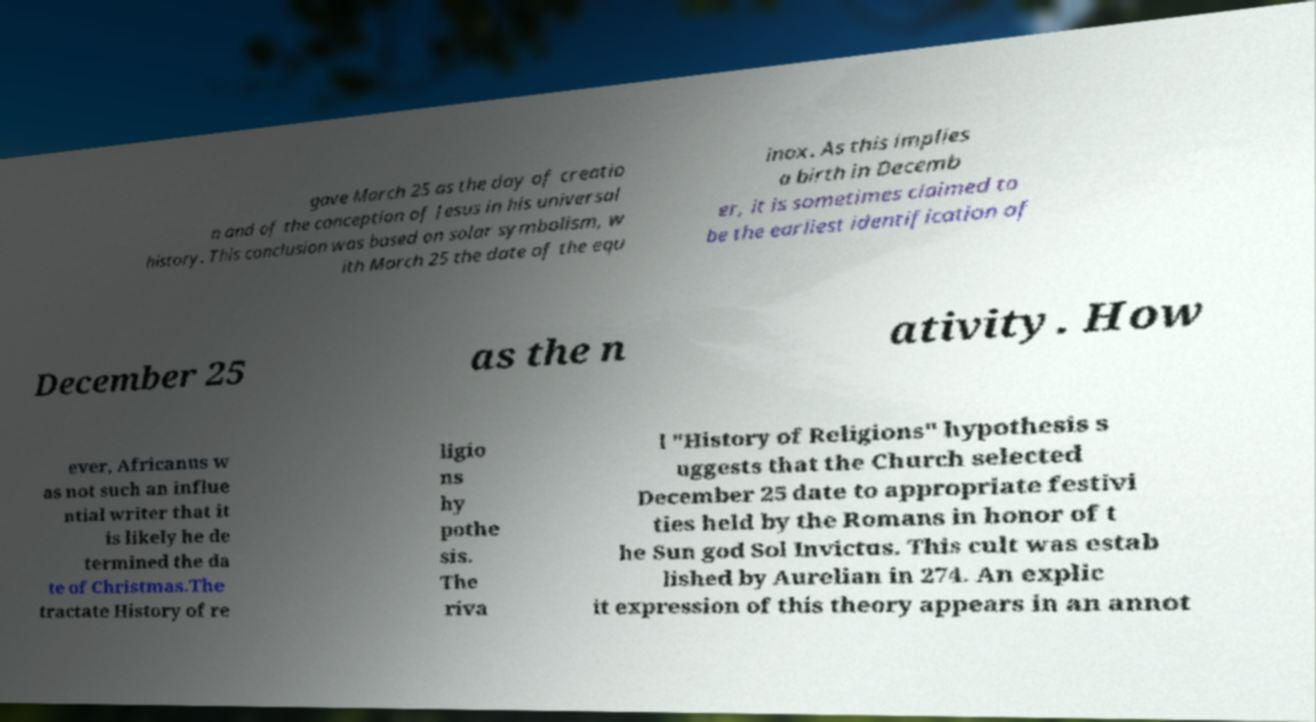Could you assist in decoding the text presented in this image and type it out clearly? gave March 25 as the day of creatio n and of the conception of Jesus in his universal history. This conclusion was based on solar symbolism, w ith March 25 the date of the equ inox. As this implies a birth in Decemb er, it is sometimes claimed to be the earliest identification of December 25 as the n ativity. How ever, Africanus w as not such an influe ntial writer that it is likely he de termined the da te of Christmas.The tractate History of re ligio ns hy pothe sis. The riva l "History of Religions" hypothesis s uggests that the Church selected December 25 date to appropriate festivi ties held by the Romans in honor of t he Sun god Sol Invictus. This cult was estab lished by Aurelian in 274. An explic it expression of this theory appears in an annot 